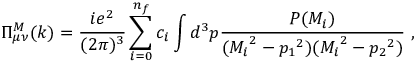Convert formula to latex. <formula><loc_0><loc_0><loc_500><loc_500>\Pi _ { \mu \nu } ^ { M } ( k ) = \frac { i e ^ { 2 } } { ( 2 \pi ) ^ { 3 } } \sum _ { i = 0 } ^ { n _ { f } } c _ { i } \int d ^ { 3 } p \frac { P ( M _ { i } ) } { ( { M _ { i } } ^ { 2 } - { p _ { 1 } } ^ { 2 } ) ( { M _ { i } } ^ { 2 } - { p _ { 2 } } ^ { 2 } ) } \, ,</formula> 